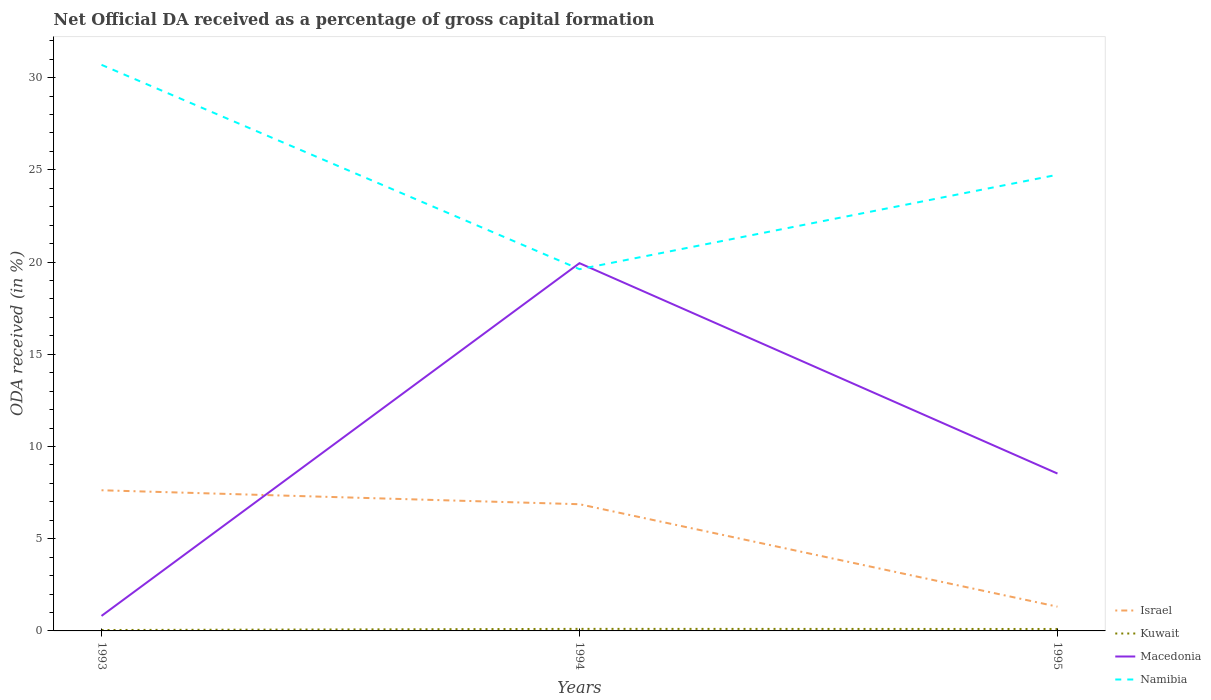Is the number of lines equal to the number of legend labels?
Provide a succinct answer. Yes. Across all years, what is the maximum net ODA received in Namibia?
Give a very brief answer. 19.61. In which year was the net ODA received in Israel maximum?
Offer a terse response. 1995. What is the total net ODA received in Kuwait in the graph?
Make the answer very short. 0.01. What is the difference between the highest and the second highest net ODA received in Macedonia?
Your answer should be very brief. 19.12. What is the difference between the highest and the lowest net ODA received in Macedonia?
Your response must be concise. 1. Is the net ODA received in Kuwait strictly greater than the net ODA received in Macedonia over the years?
Your response must be concise. Yes. How many lines are there?
Give a very brief answer. 4. Does the graph contain any zero values?
Ensure brevity in your answer.  No. Where does the legend appear in the graph?
Make the answer very short. Bottom right. How many legend labels are there?
Your response must be concise. 4. How are the legend labels stacked?
Give a very brief answer. Vertical. What is the title of the graph?
Offer a very short reply. Net Official DA received as a percentage of gross capital formation. Does "Luxembourg" appear as one of the legend labels in the graph?
Make the answer very short. No. What is the label or title of the X-axis?
Provide a succinct answer. Years. What is the label or title of the Y-axis?
Provide a succinct answer. ODA received (in %). What is the ODA received (in %) of Israel in 1993?
Offer a very short reply. 7.63. What is the ODA received (in %) of Kuwait in 1993?
Provide a short and direct response. 0.05. What is the ODA received (in %) of Macedonia in 1993?
Your answer should be compact. 0.81. What is the ODA received (in %) of Namibia in 1993?
Your answer should be compact. 30.69. What is the ODA received (in %) of Israel in 1994?
Give a very brief answer. 6.87. What is the ODA received (in %) of Kuwait in 1994?
Give a very brief answer. 0.11. What is the ODA received (in %) in Macedonia in 1994?
Offer a very short reply. 19.94. What is the ODA received (in %) of Namibia in 1994?
Offer a terse response. 19.61. What is the ODA received (in %) in Israel in 1995?
Ensure brevity in your answer.  1.31. What is the ODA received (in %) in Kuwait in 1995?
Provide a succinct answer. 0.11. What is the ODA received (in %) of Macedonia in 1995?
Your answer should be very brief. 8.53. What is the ODA received (in %) in Namibia in 1995?
Your answer should be very brief. 24.73. Across all years, what is the maximum ODA received (in %) in Israel?
Keep it short and to the point. 7.63. Across all years, what is the maximum ODA received (in %) of Kuwait?
Provide a succinct answer. 0.11. Across all years, what is the maximum ODA received (in %) of Macedonia?
Offer a very short reply. 19.94. Across all years, what is the maximum ODA received (in %) in Namibia?
Provide a succinct answer. 30.69. Across all years, what is the minimum ODA received (in %) in Israel?
Give a very brief answer. 1.31. Across all years, what is the minimum ODA received (in %) in Kuwait?
Make the answer very short. 0.05. Across all years, what is the minimum ODA received (in %) of Macedonia?
Give a very brief answer. 0.81. Across all years, what is the minimum ODA received (in %) of Namibia?
Make the answer very short. 19.61. What is the total ODA received (in %) of Israel in the graph?
Provide a short and direct response. 15.81. What is the total ODA received (in %) of Kuwait in the graph?
Your answer should be very brief. 0.27. What is the total ODA received (in %) in Macedonia in the graph?
Ensure brevity in your answer.  29.28. What is the total ODA received (in %) in Namibia in the graph?
Your answer should be very brief. 75.03. What is the difference between the ODA received (in %) in Israel in 1993 and that in 1994?
Give a very brief answer. 0.76. What is the difference between the ODA received (in %) in Kuwait in 1993 and that in 1994?
Your answer should be very brief. -0.06. What is the difference between the ODA received (in %) of Macedonia in 1993 and that in 1994?
Your answer should be compact. -19.12. What is the difference between the ODA received (in %) in Namibia in 1993 and that in 1994?
Ensure brevity in your answer.  11.08. What is the difference between the ODA received (in %) of Israel in 1993 and that in 1995?
Offer a very short reply. 6.31. What is the difference between the ODA received (in %) of Kuwait in 1993 and that in 1995?
Make the answer very short. -0.06. What is the difference between the ODA received (in %) in Macedonia in 1993 and that in 1995?
Offer a very short reply. -7.72. What is the difference between the ODA received (in %) of Namibia in 1993 and that in 1995?
Offer a terse response. 5.96. What is the difference between the ODA received (in %) of Israel in 1994 and that in 1995?
Provide a short and direct response. 5.55. What is the difference between the ODA received (in %) of Kuwait in 1994 and that in 1995?
Provide a short and direct response. 0.01. What is the difference between the ODA received (in %) in Macedonia in 1994 and that in 1995?
Provide a short and direct response. 11.41. What is the difference between the ODA received (in %) in Namibia in 1994 and that in 1995?
Provide a succinct answer. -5.12. What is the difference between the ODA received (in %) of Israel in 1993 and the ODA received (in %) of Kuwait in 1994?
Your answer should be compact. 7.51. What is the difference between the ODA received (in %) of Israel in 1993 and the ODA received (in %) of Macedonia in 1994?
Ensure brevity in your answer.  -12.31. What is the difference between the ODA received (in %) of Israel in 1993 and the ODA received (in %) of Namibia in 1994?
Your answer should be very brief. -11.98. What is the difference between the ODA received (in %) in Kuwait in 1993 and the ODA received (in %) in Macedonia in 1994?
Provide a succinct answer. -19.89. What is the difference between the ODA received (in %) in Kuwait in 1993 and the ODA received (in %) in Namibia in 1994?
Your answer should be compact. -19.56. What is the difference between the ODA received (in %) in Macedonia in 1993 and the ODA received (in %) in Namibia in 1994?
Your answer should be very brief. -18.8. What is the difference between the ODA received (in %) in Israel in 1993 and the ODA received (in %) in Kuwait in 1995?
Provide a short and direct response. 7.52. What is the difference between the ODA received (in %) in Israel in 1993 and the ODA received (in %) in Macedonia in 1995?
Make the answer very short. -0.91. What is the difference between the ODA received (in %) in Israel in 1993 and the ODA received (in %) in Namibia in 1995?
Offer a terse response. -17.11. What is the difference between the ODA received (in %) of Kuwait in 1993 and the ODA received (in %) of Macedonia in 1995?
Keep it short and to the point. -8.48. What is the difference between the ODA received (in %) of Kuwait in 1993 and the ODA received (in %) of Namibia in 1995?
Provide a succinct answer. -24.68. What is the difference between the ODA received (in %) in Macedonia in 1993 and the ODA received (in %) in Namibia in 1995?
Ensure brevity in your answer.  -23.92. What is the difference between the ODA received (in %) of Israel in 1994 and the ODA received (in %) of Kuwait in 1995?
Give a very brief answer. 6.76. What is the difference between the ODA received (in %) in Israel in 1994 and the ODA received (in %) in Macedonia in 1995?
Make the answer very short. -1.66. What is the difference between the ODA received (in %) of Israel in 1994 and the ODA received (in %) of Namibia in 1995?
Keep it short and to the point. -17.86. What is the difference between the ODA received (in %) in Kuwait in 1994 and the ODA received (in %) in Macedonia in 1995?
Your answer should be compact. -8.42. What is the difference between the ODA received (in %) in Kuwait in 1994 and the ODA received (in %) in Namibia in 1995?
Offer a terse response. -24.62. What is the difference between the ODA received (in %) in Macedonia in 1994 and the ODA received (in %) in Namibia in 1995?
Keep it short and to the point. -4.79. What is the average ODA received (in %) in Israel per year?
Ensure brevity in your answer.  5.27. What is the average ODA received (in %) in Kuwait per year?
Offer a very short reply. 0.09. What is the average ODA received (in %) in Macedonia per year?
Offer a terse response. 9.76. What is the average ODA received (in %) of Namibia per year?
Your response must be concise. 25.01. In the year 1993, what is the difference between the ODA received (in %) in Israel and ODA received (in %) in Kuwait?
Provide a succinct answer. 7.58. In the year 1993, what is the difference between the ODA received (in %) in Israel and ODA received (in %) in Macedonia?
Ensure brevity in your answer.  6.81. In the year 1993, what is the difference between the ODA received (in %) of Israel and ODA received (in %) of Namibia?
Your response must be concise. -23.06. In the year 1993, what is the difference between the ODA received (in %) of Kuwait and ODA received (in %) of Macedonia?
Offer a terse response. -0.76. In the year 1993, what is the difference between the ODA received (in %) of Kuwait and ODA received (in %) of Namibia?
Offer a terse response. -30.64. In the year 1993, what is the difference between the ODA received (in %) of Macedonia and ODA received (in %) of Namibia?
Keep it short and to the point. -29.88. In the year 1994, what is the difference between the ODA received (in %) in Israel and ODA received (in %) in Kuwait?
Offer a very short reply. 6.76. In the year 1994, what is the difference between the ODA received (in %) in Israel and ODA received (in %) in Macedonia?
Offer a terse response. -13.07. In the year 1994, what is the difference between the ODA received (in %) of Israel and ODA received (in %) of Namibia?
Keep it short and to the point. -12.74. In the year 1994, what is the difference between the ODA received (in %) in Kuwait and ODA received (in %) in Macedonia?
Offer a terse response. -19.83. In the year 1994, what is the difference between the ODA received (in %) in Kuwait and ODA received (in %) in Namibia?
Ensure brevity in your answer.  -19.5. In the year 1994, what is the difference between the ODA received (in %) of Macedonia and ODA received (in %) of Namibia?
Keep it short and to the point. 0.33. In the year 1995, what is the difference between the ODA received (in %) of Israel and ODA received (in %) of Kuwait?
Offer a terse response. 1.21. In the year 1995, what is the difference between the ODA received (in %) of Israel and ODA received (in %) of Macedonia?
Make the answer very short. -7.22. In the year 1995, what is the difference between the ODA received (in %) of Israel and ODA received (in %) of Namibia?
Make the answer very short. -23.42. In the year 1995, what is the difference between the ODA received (in %) in Kuwait and ODA received (in %) in Macedonia?
Make the answer very short. -8.43. In the year 1995, what is the difference between the ODA received (in %) in Kuwait and ODA received (in %) in Namibia?
Provide a short and direct response. -24.63. In the year 1995, what is the difference between the ODA received (in %) of Macedonia and ODA received (in %) of Namibia?
Provide a succinct answer. -16.2. What is the ratio of the ODA received (in %) in Israel in 1993 to that in 1994?
Keep it short and to the point. 1.11. What is the ratio of the ODA received (in %) of Kuwait in 1993 to that in 1994?
Give a very brief answer. 0.44. What is the ratio of the ODA received (in %) of Macedonia in 1993 to that in 1994?
Make the answer very short. 0.04. What is the ratio of the ODA received (in %) of Namibia in 1993 to that in 1994?
Ensure brevity in your answer.  1.56. What is the ratio of the ODA received (in %) in Israel in 1993 to that in 1995?
Offer a very short reply. 5.8. What is the ratio of the ODA received (in %) of Kuwait in 1993 to that in 1995?
Provide a short and direct response. 0.47. What is the ratio of the ODA received (in %) in Macedonia in 1993 to that in 1995?
Offer a very short reply. 0.1. What is the ratio of the ODA received (in %) in Namibia in 1993 to that in 1995?
Your answer should be compact. 1.24. What is the ratio of the ODA received (in %) of Israel in 1994 to that in 1995?
Offer a very short reply. 5.23. What is the ratio of the ODA received (in %) of Kuwait in 1994 to that in 1995?
Make the answer very short. 1.06. What is the ratio of the ODA received (in %) in Macedonia in 1994 to that in 1995?
Offer a very short reply. 2.34. What is the ratio of the ODA received (in %) in Namibia in 1994 to that in 1995?
Offer a very short reply. 0.79. What is the difference between the highest and the second highest ODA received (in %) of Israel?
Give a very brief answer. 0.76. What is the difference between the highest and the second highest ODA received (in %) in Kuwait?
Give a very brief answer. 0.01. What is the difference between the highest and the second highest ODA received (in %) in Macedonia?
Your answer should be compact. 11.41. What is the difference between the highest and the second highest ODA received (in %) in Namibia?
Keep it short and to the point. 5.96. What is the difference between the highest and the lowest ODA received (in %) in Israel?
Provide a short and direct response. 6.31. What is the difference between the highest and the lowest ODA received (in %) in Kuwait?
Provide a short and direct response. 0.06. What is the difference between the highest and the lowest ODA received (in %) in Macedonia?
Give a very brief answer. 19.12. What is the difference between the highest and the lowest ODA received (in %) in Namibia?
Offer a very short reply. 11.08. 